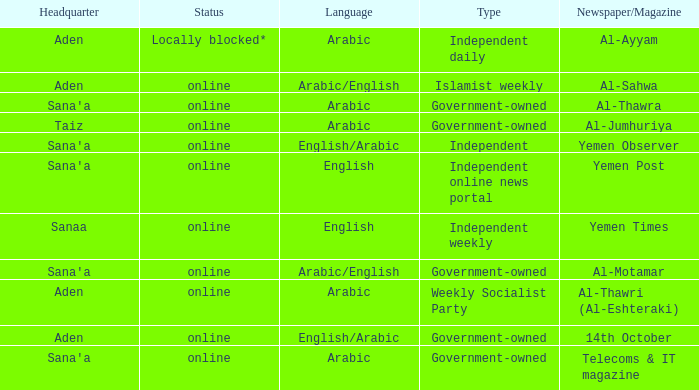In the context of an english-language independent online news portal, where can the central office be found? Sana'a. 